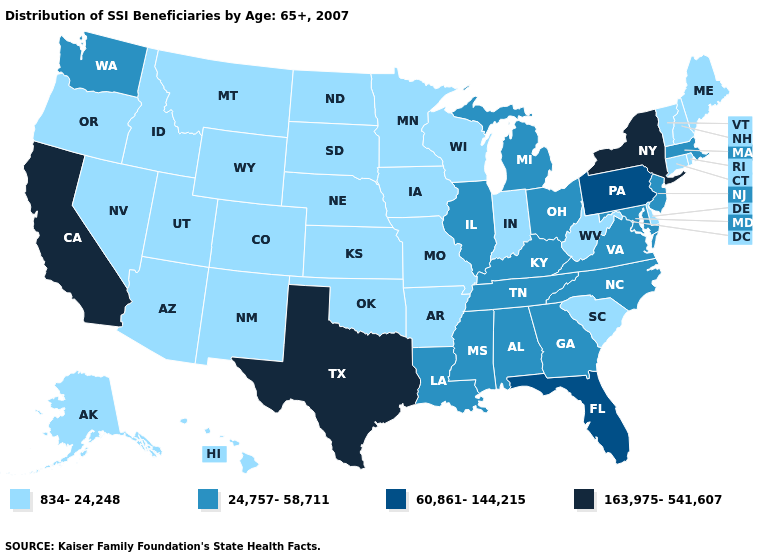What is the value of Washington?
Keep it brief. 24,757-58,711. Name the states that have a value in the range 163,975-541,607?
Be succinct. California, New York, Texas. Which states have the lowest value in the USA?
Quick response, please. Alaska, Arizona, Arkansas, Colorado, Connecticut, Delaware, Hawaii, Idaho, Indiana, Iowa, Kansas, Maine, Minnesota, Missouri, Montana, Nebraska, Nevada, New Hampshire, New Mexico, North Dakota, Oklahoma, Oregon, Rhode Island, South Carolina, South Dakota, Utah, Vermont, West Virginia, Wisconsin, Wyoming. Does New York have the highest value in the USA?
Keep it brief. Yes. Name the states that have a value in the range 60,861-144,215?
Be succinct. Florida, Pennsylvania. Name the states that have a value in the range 163,975-541,607?
Be succinct. California, New York, Texas. Does Ohio have the highest value in the MidWest?
Answer briefly. Yes. What is the highest value in the USA?
Be succinct. 163,975-541,607. Which states have the lowest value in the Northeast?
Write a very short answer. Connecticut, Maine, New Hampshire, Rhode Island, Vermont. Name the states that have a value in the range 24,757-58,711?
Answer briefly. Alabama, Georgia, Illinois, Kentucky, Louisiana, Maryland, Massachusetts, Michigan, Mississippi, New Jersey, North Carolina, Ohio, Tennessee, Virginia, Washington. How many symbols are there in the legend?
Quick response, please. 4. What is the value of Missouri?
Concise answer only. 834-24,248. Among the states that border Nevada , does Utah have the highest value?
Write a very short answer. No. What is the highest value in the USA?
Short answer required. 163,975-541,607. Does Nevada have the lowest value in the West?
Be succinct. Yes. 